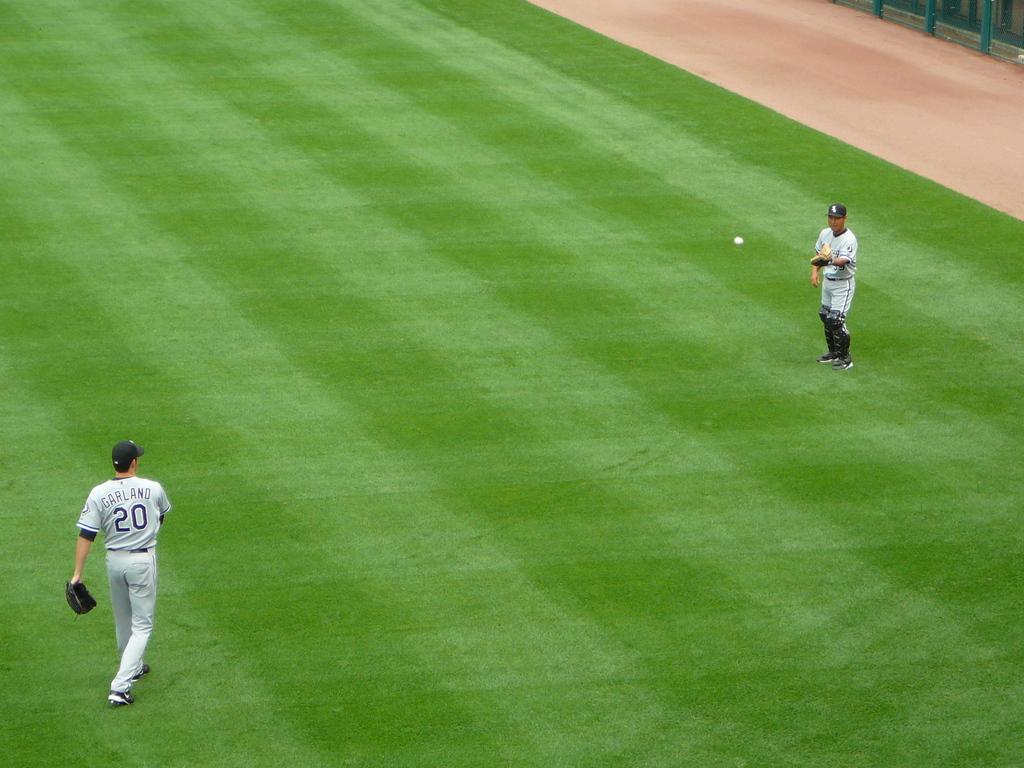What is the man on the lefts jersey number?
Offer a very short reply. 20. What number can be seen on the jersey?
Your answer should be compact. 20. 